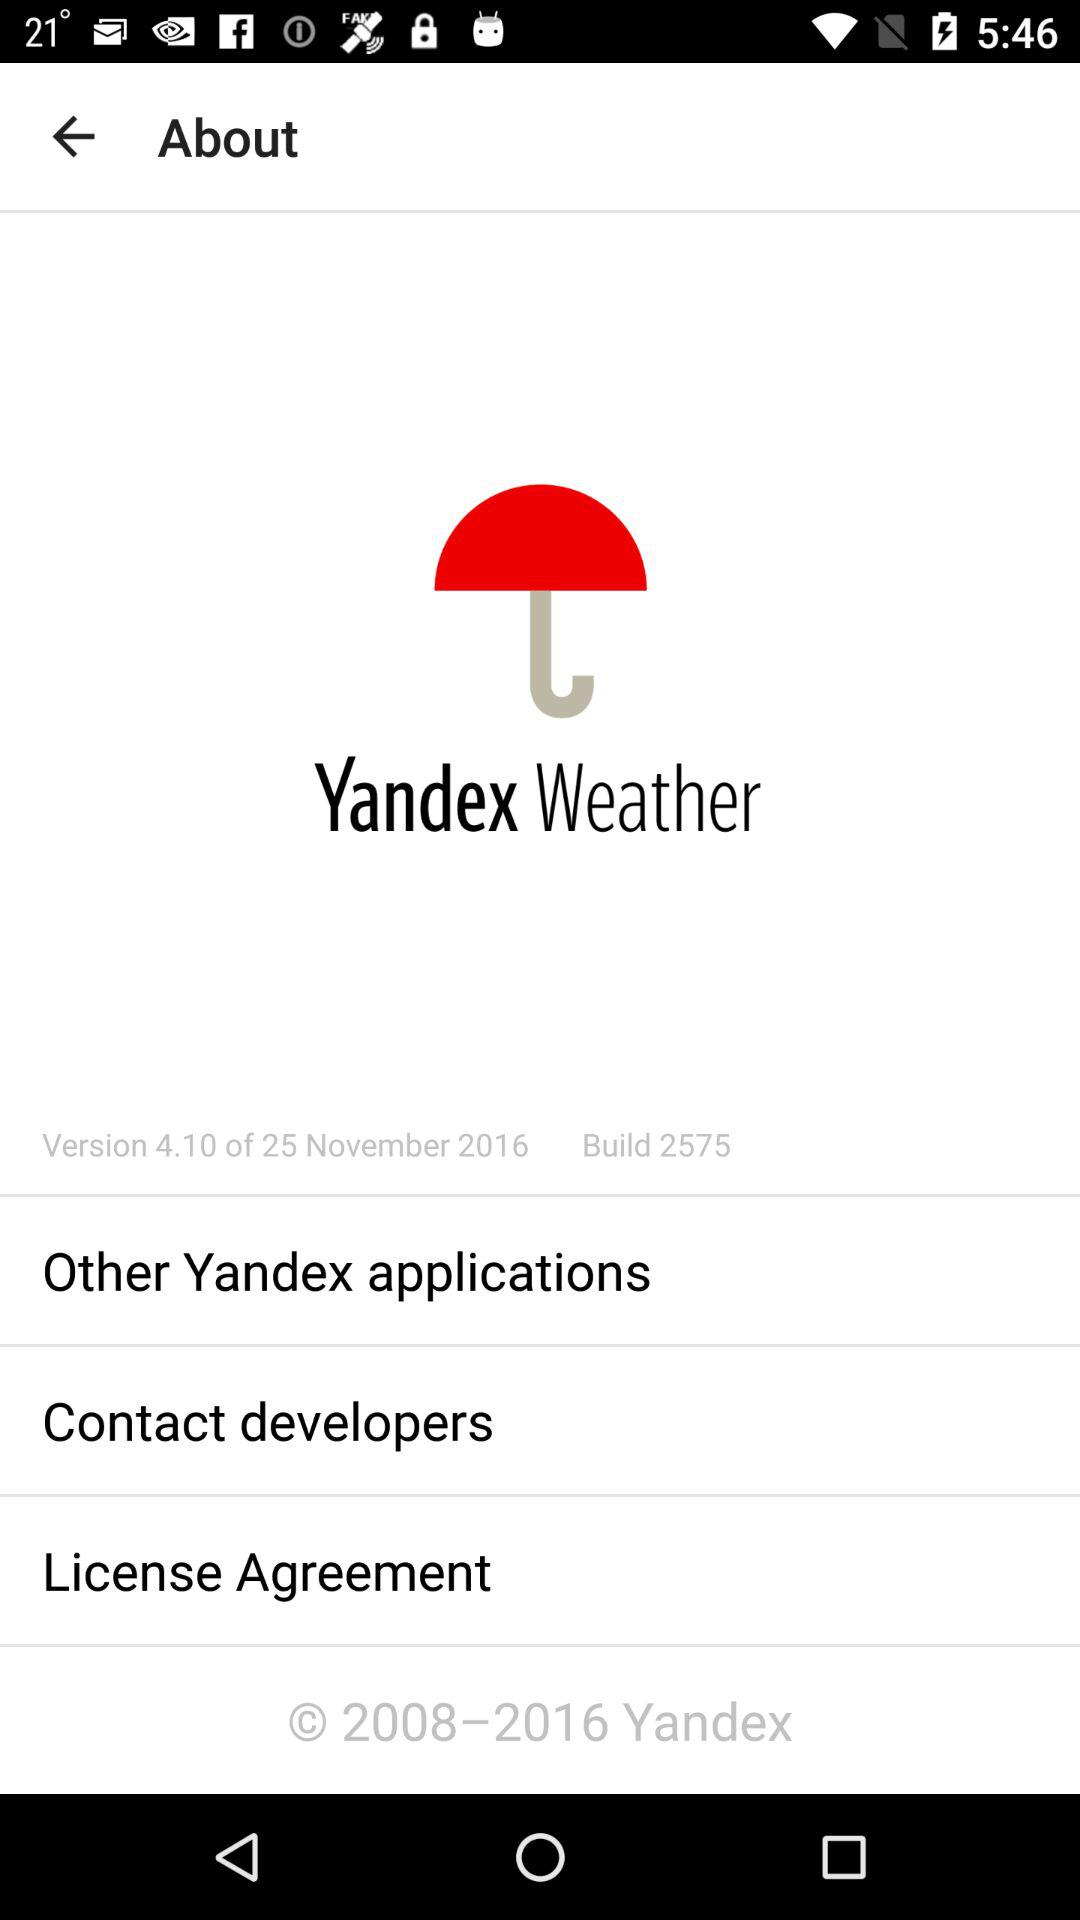What is the date of the version? The date of the version is November 25, 2016. 